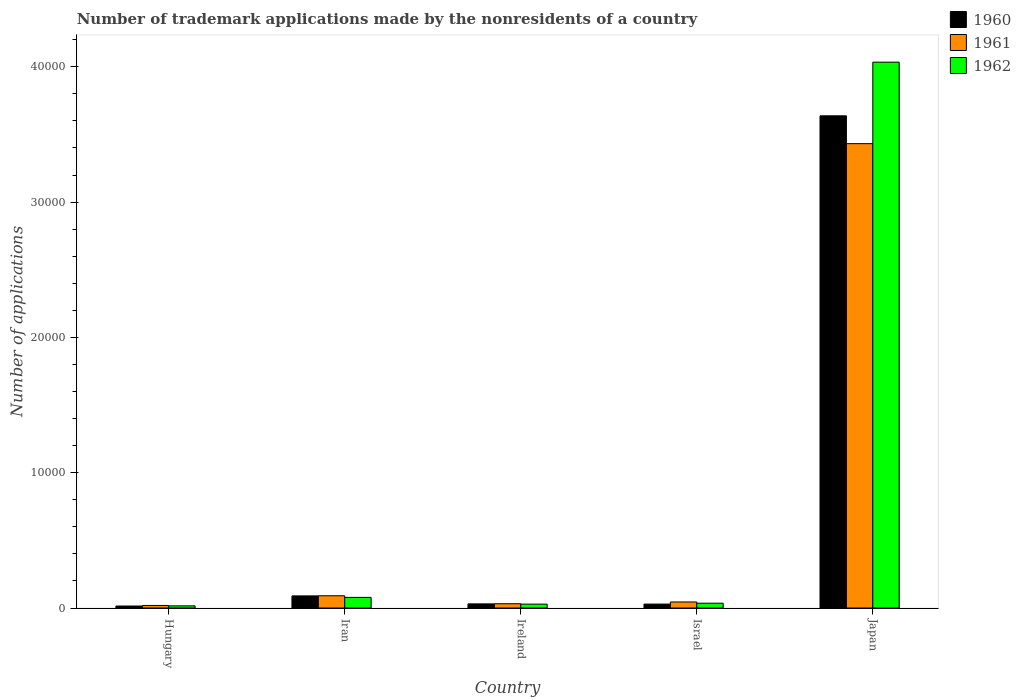How many different coloured bars are there?
Offer a very short reply. 3. Are the number of bars on each tick of the X-axis equal?
Your answer should be compact. Yes. How many bars are there on the 5th tick from the right?
Give a very brief answer. 3. What is the label of the 2nd group of bars from the left?
Make the answer very short. Iran. What is the number of trademark applications made by the nonresidents in 1961 in Israel?
Make the answer very short. 446. Across all countries, what is the maximum number of trademark applications made by the nonresidents in 1961?
Your answer should be very brief. 3.43e+04. Across all countries, what is the minimum number of trademark applications made by the nonresidents in 1962?
Your response must be concise. 158. In which country was the number of trademark applications made by the nonresidents in 1962 maximum?
Provide a short and direct response. Japan. In which country was the number of trademark applications made by the nonresidents in 1962 minimum?
Provide a succinct answer. Hungary. What is the total number of trademark applications made by the nonresidents in 1962 in the graph?
Keep it short and to the point. 4.19e+04. What is the difference between the number of trademark applications made by the nonresidents in 1960 in Hungary and that in Japan?
Keep it short and to the point. -3.62e+04. What is the difference between the number of trademark applications made by the nonresidents in 1961 in Japan and the number of trademark applications made by the nonresidents in 1962 in Israel?
Keep it short and to the point. 3.40e+04. What is the average number of trademark applications made by the nonresidents in 1962 per country?
Offer a very short reply. 8386. What is the difference between the number of trademark applications made by the nonresidents of/in 1960 and number of trademark applications made by the nonresidents of/in 1961 in Israel?
Give a very brief answer. -156. What is the ratio of the number of trademark applications made by the nonresidents in 1961 in Hungary to that in Ireland?
Provide a succinct answer. 0.59. Is the number of trademark applications made by the nonresidents in 1962 in Hungary less than that in Israel?
Offer a very short reply. Yes. What is the difference between the highest and the second highest number of trademark applications made by the nonresidents in 1960?
Your response must be concise. 3.61e+04. What is the difference between the highest and the lowest number of trademark applications made by the nonresidents in 1961?
Give a very brief answer. 3.41e+04. What does the 3rd bar from the left in Japan represents?
Ensure brevity in your answer.  1962. What is the difference between two consecutive major ticks on the Y-axis?
Give a very brief answer. 10000. Does the graph contain any zero values?
Make the answer very short. No. Does the graph contain grids?
Offer a very short reply. No. Where does the legend appear in the graph?
Provide a succinct answer. Top right. How are the legend labels stacked?
Your answer should be very brief. Vertical. What is the title of the graph?
Make the answer very short. Number of trademark applications made by the nonresidents of a country. What is the label or title of the Y-axis?
Offer a terse response. Number of applications. What is the Number of applications in 1960 in Hungary?
Your answer should be compact. 147. What is the Number of applications in 1961 in Hungary?
Give a very brief answer. 188. What is the Number of applications of 1962 in Hungary?
Ensure brevity in your answer.  158. What is the Number of applications in 1960 in Iran?
Give a very brief answer. 895. What is the Number of applications of 1961 in Iran?
Offer a terse response. 905. What is the Number of applications in 1962 in Iran?
Make the answer very short. 786. What is the Number of applications in 1960 in Ireland?
Offer a terse response. 305. What is the Number of applications of 1961 in Ireland?
Your answer should be very brief. 316. What is the Number of applications in 1962 in Ireland?
Your answer should be compact. 288. What is the Number of applications in 1960 in Israel?
Your answer should be very brief. 290. What is the Number of applications in 1961 in Israel?
Provide a short and direct response. 446. What is the Number of applications of 1962 in Israel?
Offer a terse response. 355. What is the Number of applications of 1960 in Japan?
Keep it short and to the point. 3.64e+04. What is the Number of applications in 1961 in Japan?
Keep it short and to the point. 3.43e+04. What is the Number of applications of 1962 in Japan?
Your response must be concise. 4.03e+04. Across all countries, what is the maximum Number of applications of 1960?
Give a very brief answer. 3.64e+04. Across all countries, what is the maximum Number of applications in 1961?
Make the answer very short. 3.43e+04. Across all countries, what is the maximum Number of applications of 1962?
Your answer should be very brief. 4.03e+04. Across all countries, what is the minimum Number of applications in 1960?
Your answer should be very brief. 147. Across all countries, what is the minimum Number of applications in 1961?
Keep it short and to the point. 188. Across all countries, what is the minimum Number of applications of 1962?
Your response must be concise. 158. What is the total Number of applications of 1960 in the graph?
Your answer should be compact. 3.80e+04. What is the total Number of applications of 1961 in the graph?
Offer a very short reply. 3.62e+04. What is the total Number of applications in 1962 in the graph?
Offer a terse response. 4.19e+04. What is the difference between the Number of applications in 1960 in Hungary and that in Iran?
Your answer should be compact. -748. What is the difference between the Number of applications of 1961 in Hungary and that in Iran?
Your answer should be very brief. -717. What is the difference between the Number of applications in 1962 in Hungary and that in Iran?
Keep it short and to the point. -628. What is the difference between the Number of applications in 1960 in Hungary and that in Ireland?
Offer a terse response. -158. What is the difference between the Number of applications of 1961 in Hungary and that in Ireland?
Your answer should be very brief. -128. What is the difference between the Number of applications in 1962 in Hungary and that in Ireland?
Your answer should be compact. -130. What is the difference between the Number of applications in 1960 in Hungary and that in Israel?
Offer a very short reply. -143. What is the difference between the Number of applications in 1961 in Hungary and that in Israel?
Give a very brief answer. -258. What is the difference between the Number of applications of 1962 in Hungary and that in Israel?
Offer a very short reply. -197. What is the difference between the Number of applications in 1960 in Hungary and that in Japan?
Keep it short and to the point. -3.62e+04. What is the difference between the Number of applications in 1961 in Hungary and that in Japan?
Give a very brief answer. -3.41e+04. What is the difference between the Number of applications of 1962 in Hungary and that in Japan?
Offer a very short reply. -4.02e+04. What is the difference between the Number of applications in 1960 in Iran and that in Ireland?
Your answer should be very brief. 590. What is the difference between the Number of applications of 1961 in Iran and that in Ireland?
Your answer should be very brief. 589. What is the difference between the Number of applications in 1962 in Iran and that in Ireland?
Your answer should be very brief. 498. What is the difference between the Number of applications in 1960 in Iran and that in Israel?
Your answer should be very brief. 605. What is the difference between the Number of applications of 1961 in Iran and that in Israel?
Provide a succinct answer. 459. What is the difference between the Number of applications in 1962 in Iran and that in Israel?
Your answer should be compact. 431. What is the difference between the Number of applications in 1960 in Iran and that in Japan?
Keep it short and to the point. -3.55e+04. What is the difference between the Number of applications in 1961 in Iran and that in Japan?
Make the answer very short. -3.34e+04. What is the difference between the Number of applications of 1962 in Iran and that in Japan?
Offer a terse response. -3.96e+04. What is the difference between the Number of applications of 1960 in Ireland and that in Israel?
Make the answer very short. 15. What is the difference between the Number of applications in 1961 in Ireland and that in Israel?
Give a very brief answer. -130. What is the difference between the Number of applications of 1962 in Ireland and that in Israel?
Provide a short and direct response. -67. What is the difference between the Number of applications of 1960 in Ireland and that in Japan?
Your answer should be compact. -3.61e+04. What is the difference between the Number of applications of 1961 in Ireland and that in Japan?
Provide a short and direct response. -3.40e+04. What is the difference between the Number of applications in 1962 in Ireland and that in Japan?
Your answer should be very brief. -4.01e+04. What is the difference between the Number of applications of 1960 in Israel and that in Japan?
Provide a succinct answer. -3.61e+04. What is the difference between the Number of applications in 1961 in Israel and that in Japan?
Offer a terse response. -3.39e+04. What is the difference between the Number of applications in 1962 in Israel and that in Japan?
Your answer should be compact. -4.00e+04. What is the difference between the Number of applications in 1960 in Hungary and the Number of applications in 1961 in Iran?
Offer a terse response. -758. What is the difference between the Number of applications in 1960 in Hungary and the Number of applications in 1962 in Iran?
Provide a succinct answer. -639. What is the difference between the Number of applications in 1961 in Hungary and the Number of applications in 1962 in Iran?
Your answer should be compact. -598. What is the difference between the Number of applications in 1960 in Hungary and the Number of applications in 1961 in Ireland?
Offer a very short reply. -169. What is the difference between the Number of applications of 1960 in Hungary and the Number of applications of 1962 in Ireland?
Your response must be concise. -141. What is the difference between the Number of applications of 1961 in Hungary and the Number of applications of 1962 in Ireland?
Your answer should be compact. -100. What is the difference between the Number of applications of 1960 in Hungary and the Number of applications of 1961 in Israel?
Offer a very short reply. -299. What is the difference between the Number of applications in 1960 in Hungary and the Number of applications in 1962 in Israel?
Provide a short and direct response. -208. What is the difference between the Number of applications in 1961 in Hungary and the Number of applications in 1962 in Israel?
Give a very brief answer. -167. What is the difference between the Number of applications in 1960 in Hungary and the Number of applications in 1961 in Japan?
Provide a short and direct response. -3.42e+04. What is the difference between the Number of applications of 1960 in Hungary and the Number of applications of 1962 in Japan?
Your response must be concise. -4.02e+04. What is the difference between the Number of applications of 1961 in Hungary and the Number of applications of 1962 in Japan?
Provide a short and direct response. -4.02e+04. What is the difference between the Number of applications in 1960 in Iran and the Number of applications in 1961 in Ireland?
Offer a terse response. 579. What is the difference between the Number of applications of 1960 in Iran and the Number of applications of 1962 in Ireland?
Keep it short and to the point. 607. What is the difference between the Number of applications in 1961 in Iran and the Number of applications in 1962 in Ireland?
Keep it short and to the point. 617. What is the difference between the Number of applications of 1960 in Iran and the Number of applications of 1961 in Israel?
Keep it short and to the point. 449. What is the difference between the Number of applications in 1960 in Iran and the Number of applications in 1962 in Israel?
Provide a succinct answer. 540. What is the difference between the Number of applications of 1961 in Iran and the Number of applications of 1962 in Israel?
Provide a short and direct response. 550. What is the difference between the Number of applications of 1960 in Iran and the Number of applications of 1961 in Japan?
Provide a succinct answer. -3.34e+04. What is the difference between the Number of applications in 1960 in Iran and the Number of applications in 1962 in Japan?
Keep it short and to the point. -3.94e+04. What is the difference between the Number of applications in 1961 in Iran and the Number of applications in 1962 in Japan?
Your response must be concise. -3.94e+04. What is the difference between the Number of applications of 1960 in Ireland and the Number of applications of 1961 in Israel?
Your response must be concise. -141. What is the difference between the Number of applications of 1960 in Ireland and the Number of applications of 1962 in Israel?
Make the answer very short. -50. What is the difference between the Number of applications of 1961 in Ireland and the Number of applications of 1962 in Israel?
Provide a short and direct response. -39. What is the difference between the Number of applications of 1960 in Ireland and the Number of applications of 1961 in Japan?
Give a very brief answer. -3.40e+04. What is the difference between the Number of applications in 1960 in Ireland and the Number of applications in 1962 in Japan?
Offer a terse response. -4.00e+04. What is the difference between the Number of applications in 1961 in Ireland and the Number of applications in 1962 in Japan?
Give a very brief answer. -4.00e+04. What is the difference between the Number of applications of 1960 in Israel and the Number of applications of 1961 in Japan?
Offer a terse response. -3.40e+04. What is the difference between the Number of applications of 1960 in Israel and the Number of applications of 1962 in Japan?
Provide a succinct answer. -4.01e+04. What is the difference between the Number of applications in 1961 in Israel and the Number of applications in 1962 in Japan?
Give a very brief answer. -3.99e+04. What is the average Number of applications of 1960 per country?
Provide a succinct answer. 7602.8. What is the average Number of applications of 1961 per country?
Offer a very short reply. 7235. What is the average Number of applications of 1962 per country?
Your response must be concise. 8386. What is the difference between the Number of applications in 1960 and Number of applications in 1961 in Hungary?
Offer a very short reply. -41. What is the difference between the Number of applications of 1960 and Number of applications of 1962 in Hungary?
Make the answer very short. -11. What is the difference between the Number of applications in 1960 and Number of applications in 1961 in Iran?
Give a very brief answer. -10. What is the difference between the Number of applications of 1960 and Number of applications of 1962 in Iran?
Your answer should be compact. 109. What is the difference between the Number of applications of 1961 and Number of applications of 1962 in Iran?
Offer a terse response. 119. What is the difference between the Number of applications of 1960 and Number of applications of 1961 in Ireland?
Keep it short and to the point. -11. What is the difference between the Number of applications in 1960 and Number of applications in 1962 in Ireland?
Your response must be concise. 17. What is the difference between the Number of applications in 1960 and Number of applications in 1961 in Israel?
Provide a succinct answer. -156. What is the difference between the Number of applications in 1960 and Number of applications in 1962 in Israel?
Your answer should be very brief. -65. What is the difference between the Number of applications in 1961 and Number of applications in 1962 in Israel?
Provide a succinct answer. 91. What is the difference between the Number of applications in 1960 and Number of applications in 1961 in Japan?
Offer a terse response. 2057. What is the difference between the Number of applications of 1960 and Number of applications of 1962 in Japan?
Your response must be concise. -3966. What is the difference between the Number of applications in 1961 and Number of applications in 1962 in Japan?
Your answer should be compact. -6023. What is the ratio of the Number of applications of 1960 in Hungary to that in Iran?
Provide a short and direct response. 0.16. What is the ratio of the Number of applications of 1961 in Hungary to that in Iran?
Provide a short and direct response. 0.21. What is the ratio of the Number of applications in 1962 in Hungary to that in Iran?
Provide a succinct answer. 0.2. What is the ratio of the Number of applications of 1960 in Hungary to that in Ireland?
Offer a very short reply. 0.48. What is the ratio of the Number of applications of 1961 in Hungary to that in Ireland?
Ensure brevity in your answer.  0.59. What is the ratio of the Number of applications of 1962 in Hungary to that in Ireland?
Your response must be concise. 0.55. What is the ratio of the Number of applications of 1960 in Hungary to that in Israel?
Provide a short and direct response. 0.51. What is the ratio of the Number of applications in 1961 in Hungary to that in Israel?
Make the answer very short. 0.42. What is the ratio of the Number of applications in 1962 in Hungary to that in Israel?
Provide a short and direct response. 0.45. What is the ratio of the Number of applications of 1960 in Hungary to that in Japan?
Your answer should be compact. 0. What is the ratio of the Number of applications in 1961 in Hungary to that in Japan?
Give a very brief answer. 0.01. What is the ratio of the Number of applications of 1962 in Hungary to that in Japan?
Offer a terse response. 0. What is the ratio of the Number of applications in 1960 in Iran to that in Ireland?
Make the answer very short. 2.93. What is the ratio of the Number of applications in 1961 in Iran to that in Ireland?
Provide a succinct answer. 2.86. What is the ratio of the Number of applications in 1962 in Iran to that in Ireland?
Ensure brevity in your answer.  2.73. What is the ratio of the Number of applications in 1960 in Iran to that in Israel?
Give a very brief answer. 3.09. What is the ratio of the Number of applications of 1961 in Iran to that in Israel?
Offer a terse response. 2.03. What is the ratio of the Number of applications of 1962 in Iran to that in Israel?
Your response must be concise. 2.21. What is the ratio of the Number of applications in 1960 in Iran to that in Japan?
Offer a very short reply. 0.02. What is the ratio of the Number of applications of 1961 in Iran to that in Japan?
Make the answer very short. 0.03. What is the ratio of the Number of applications of 1962 in Iran to that in Japan?
Offer a terse response. 0.02. What is the ratio of the Number of applications in 1960 in Ireland to that in Israel?
Your answer should be very brief. 1.05. What is the ratio of the Number of applications of 1961 in Ireland to that in Israel?
Your answer should be very brief. 0.71. What is the ratio of the Number of applications of 1962 in Ireland to that in Israel?
Your response must be concise. 0.81. What is the ratio of the Number of applications of 1960 in Ireland to that in Japan?
Make the answer very short. 0.01. What is the ratio of the Number of applications in 1961 in Ireland to that in Japan?
Make the answer very short. 0.01. What is the ratio of the Number of applications in 1962 in Ireland to that in Japan?
Your answer should be very brief. 0.01. What is the ratio of the Number of applications of 1960 in Israel to that in Japan?
Offer a terse response. 0.01. What is the ratio of the Number of applications in 1961 in Israel to that in Japan?
Offer a very short reply. 0.01. What is the ratio of the Number of applications of 1962 in Israel to that in Japan?
Provide a short and direct response. 0.01. What is the difference between the highest and the second highest Number of applications in 1960?
Your response must be concise. 3.55e+04. What is the difference between the highest and the second highest Number of applications in 1961?
Offer a terse response. 3.34e+04. What is the difference between the highest and the second highest Number of applications in 1962?
Make the answer very short. 3.96e+04. What is the difference between the highest and the lowest Number of applications in 1960?
Provide a succinct answer. 3.62e+04. What is the difference between the highest and the lowest Number of applications in 1961?
Keep it short and to the point. 3.41e+04. What is the difference between the highest and the lowest Number of applications in 1962?
Keep it short and to the point. 4.02e+04. 